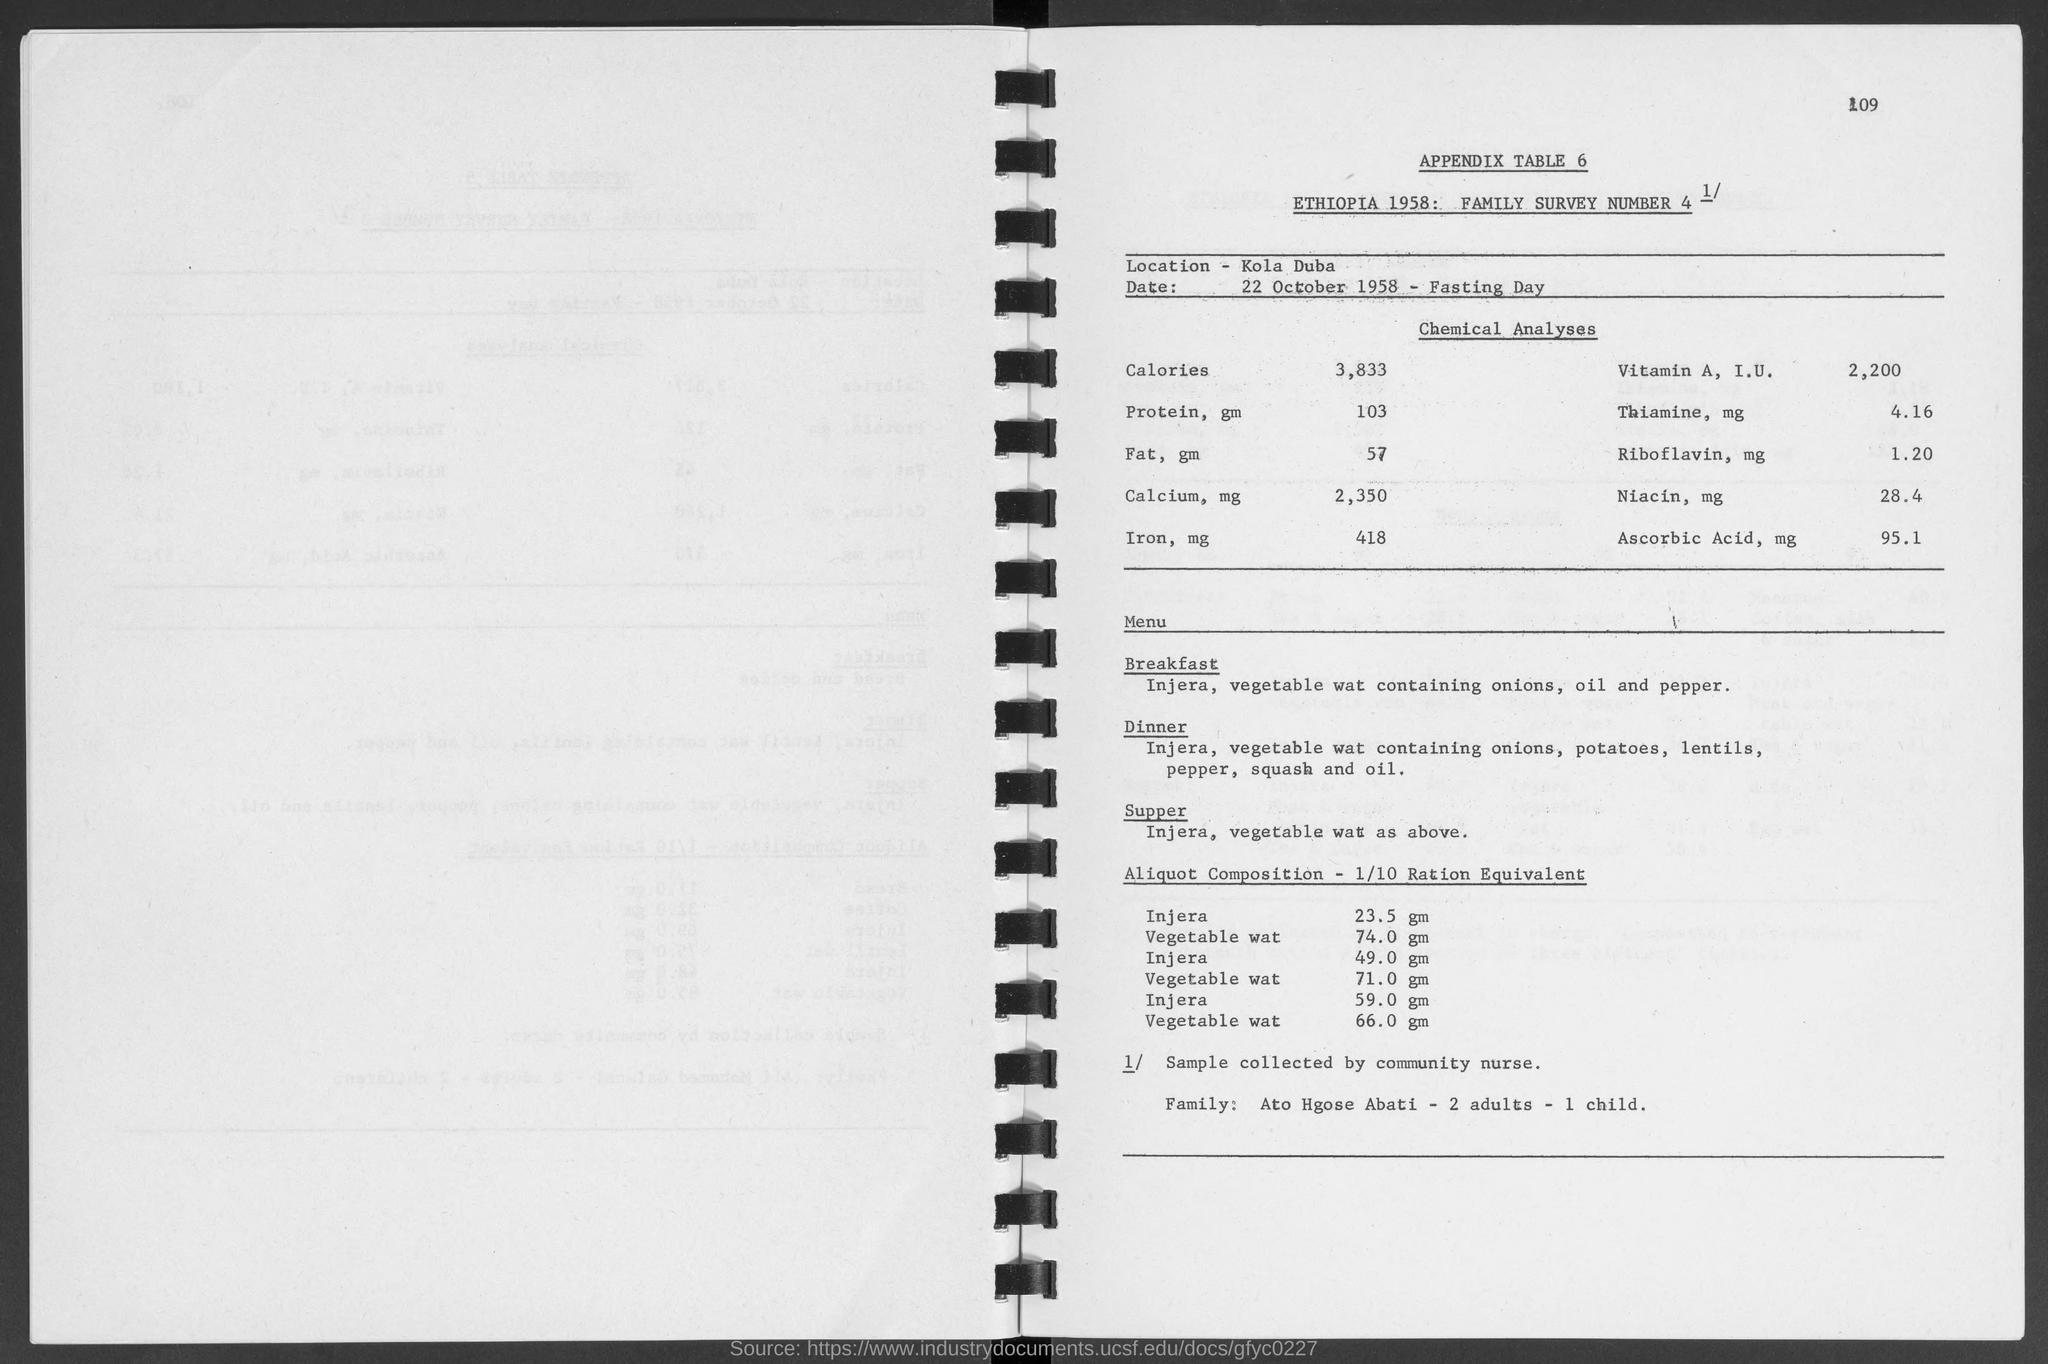What is the location on the table?
Provide a short and direct response. KOLA DUBA. What is the common menu item ?
Your answer should be very brief. Injera, vegetable wat. By whom the sample collected
Your answer should be compact. COMMUNITY NURSE. 